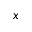Convert formula to latex. <formula><loc_0><loc_0><loc_500><loc_500>x</formula> 